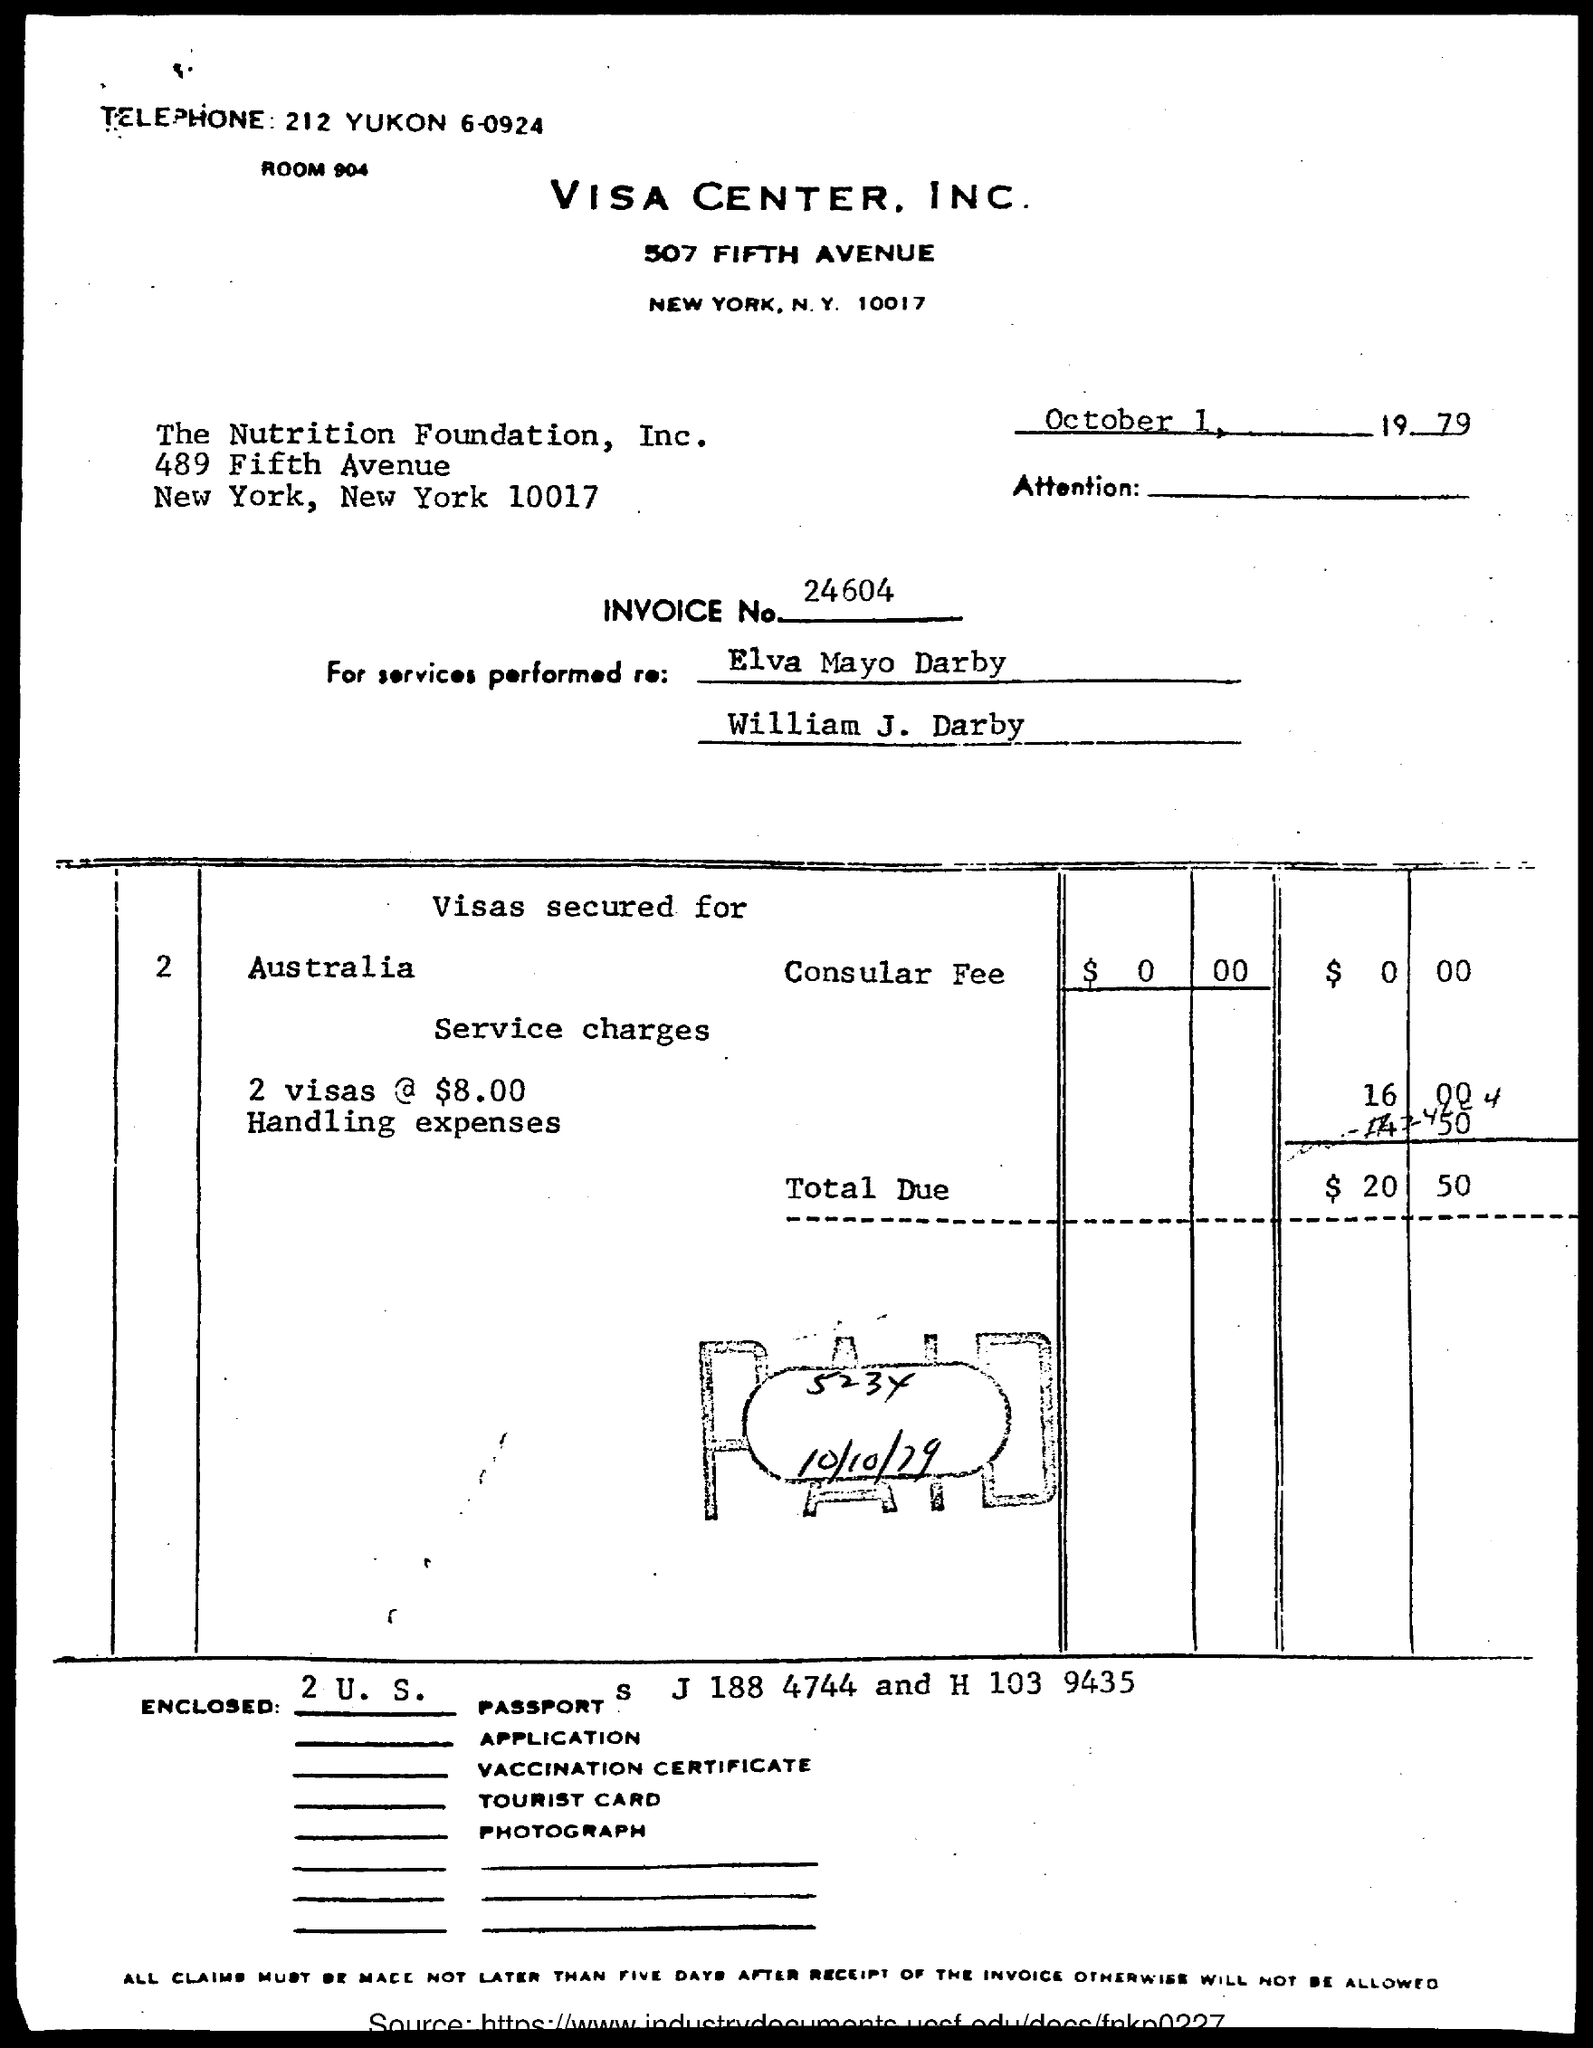What is the telephone number of visa center, inc.?
Keep it short and to the point. 212 YUKON 6-0924. What is the room no. of visa center, inc.?
Your answer should be compact. 904. What is the invoice no.?
Make the answer very short. 24604. What is the total due?
Your response must be concise. $20.50. What is date and year mentioned in the document ?
Offer a terse response. October 1, 1979. To which place are visas secured for?
Make the answer very short. Australia. 